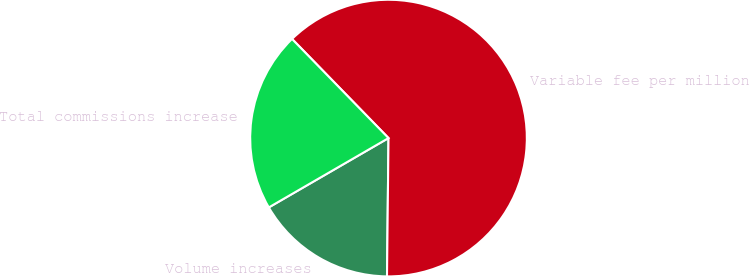Convert chart to OTSL. <chart><loc_0><loc_0><loc_500><loc_500><pie_chart><fcel>Volume increases<fcel>Variable fee per million<fcel>Total commissions increase<nl><fcel>16.47%<fcel>62.46%<fcel>21.07%<nl></chart> 